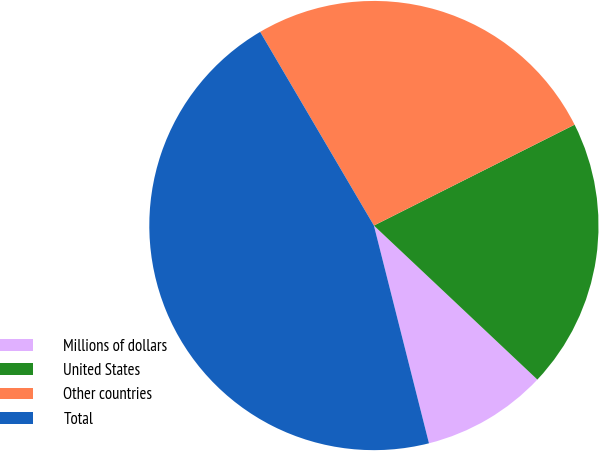Convert chart. <chart><loc_0><loc_0><loc_500><loc_500><pie_chart><fcel>Millions of dollars<fcel>United States<fcel>Other countries<fcel>Total<nl><fcel>9.03%<fcel>19.44%<fcel>26.04%<fcel>45.49%<nl></chart> 